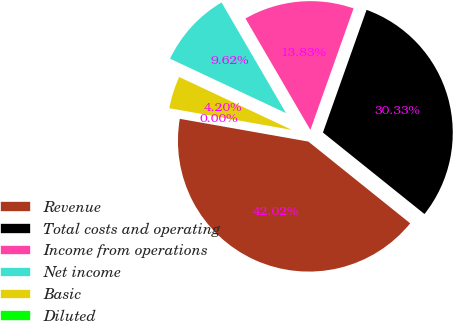<chart> <loc_0><loc_0><loc_500><loc_500><pie_chart><fcel>Revenue<fcel>Total costs and operating<fcel>Income from operations<fcel>Net income<fcel>Basic<fcel>Diluted<nl><fcel>42.02%<fcel>30.33%<fcel>13.83%<fcel>9.62%<fcel>4.2%<fcel>0.0%<nl></chart> 